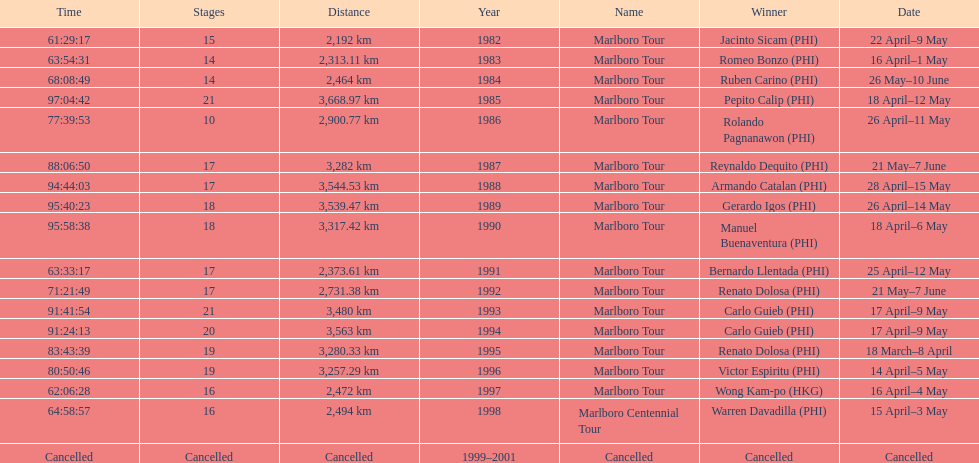Who was the only winner to have their time below 61:45:00? Jacinto Sicam. 